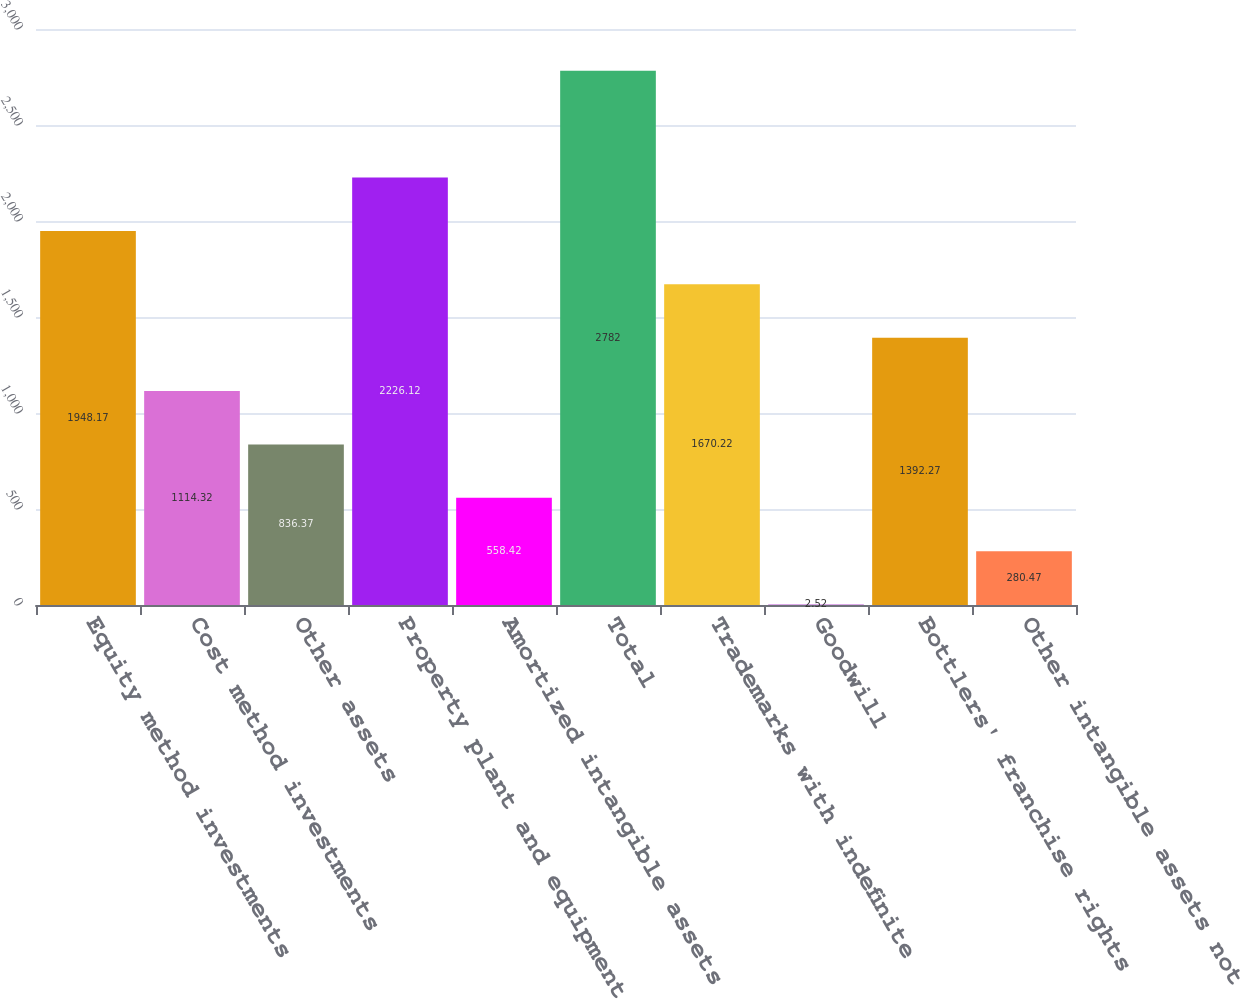Convert chart to OTSL. <chart><loc_0><loc_0><loc_500><loc_500><bar_chart><fcel>Equity method investments<fcel>Cost method investments<fcel>Other assets<fcel>Property plant and equipment<fcel>Amortized intangible assets<fcel>Total<fcel>Trademarks with indefinite<fcel>Goodwill<fcel>Bottlers' franchise rights<fcel>Other intangible assets not<nl><fcel>1948.17<fcel>1114.32<fcel>836.37<fcel>2226.12<fcel>558.42<fcel>2782<fcel>1670.22<fcel>2.52<fcel>1392.27<fcel>280.47<nl></chart> 